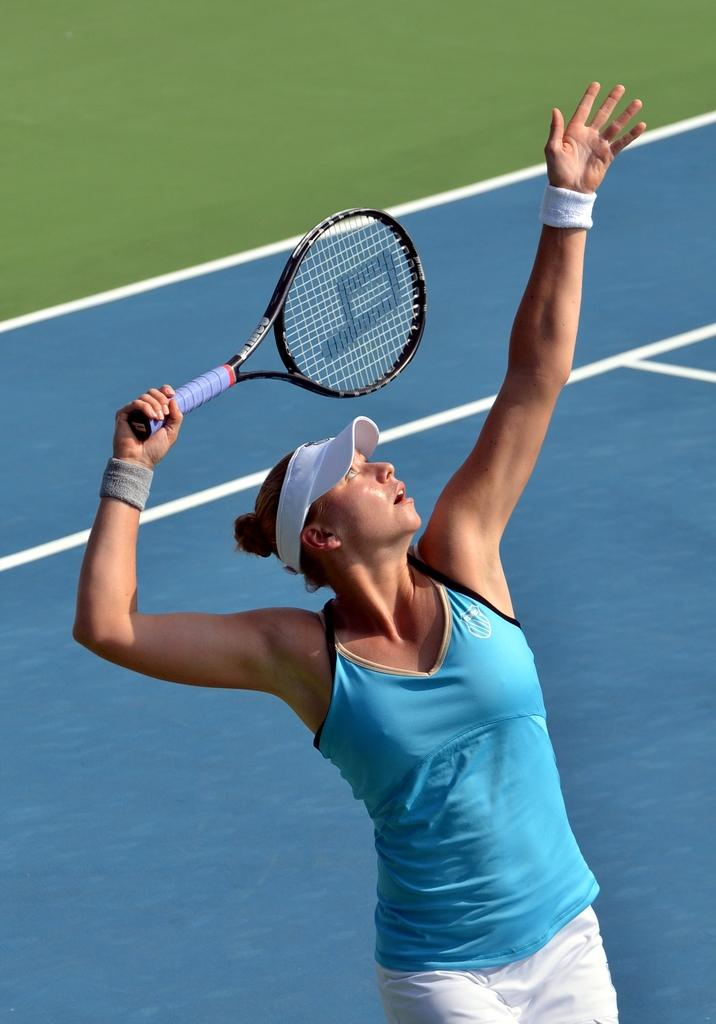Who is present in the image? There is a woman in the image. What is the woman holding in the image? The woman is holding a bat. Where is the woman standing in the image? The woman is standing in a ground. How many sisters can be seen in the image? There are no sisters present in the image; it only features a woman holding a bat and standing in a ground. 